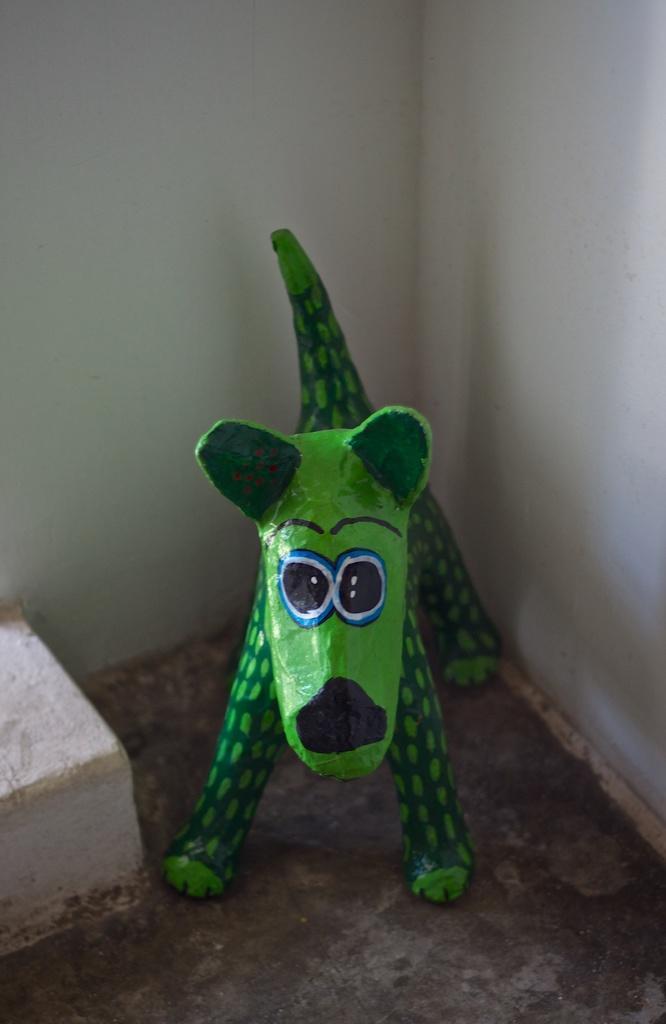How would you summarize this image in a sentence or two? In this picture we can see an object and a toy on the floor and in the background we can see walls. 